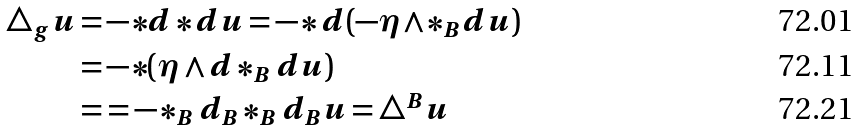<formula> <loc_0><loc_0><loc_500><loc_500>\triangle _ { g } u = & - * d * d u = - * d ( - \eta \wedge * _ { B } d u ) \\ = & - * ( \eta \wedge d * _ { B } d u ) \\ = & = - * _ { B } d _ { B } * _ { B } d _ { B } u = \triangle ^ { B } u</formula> 